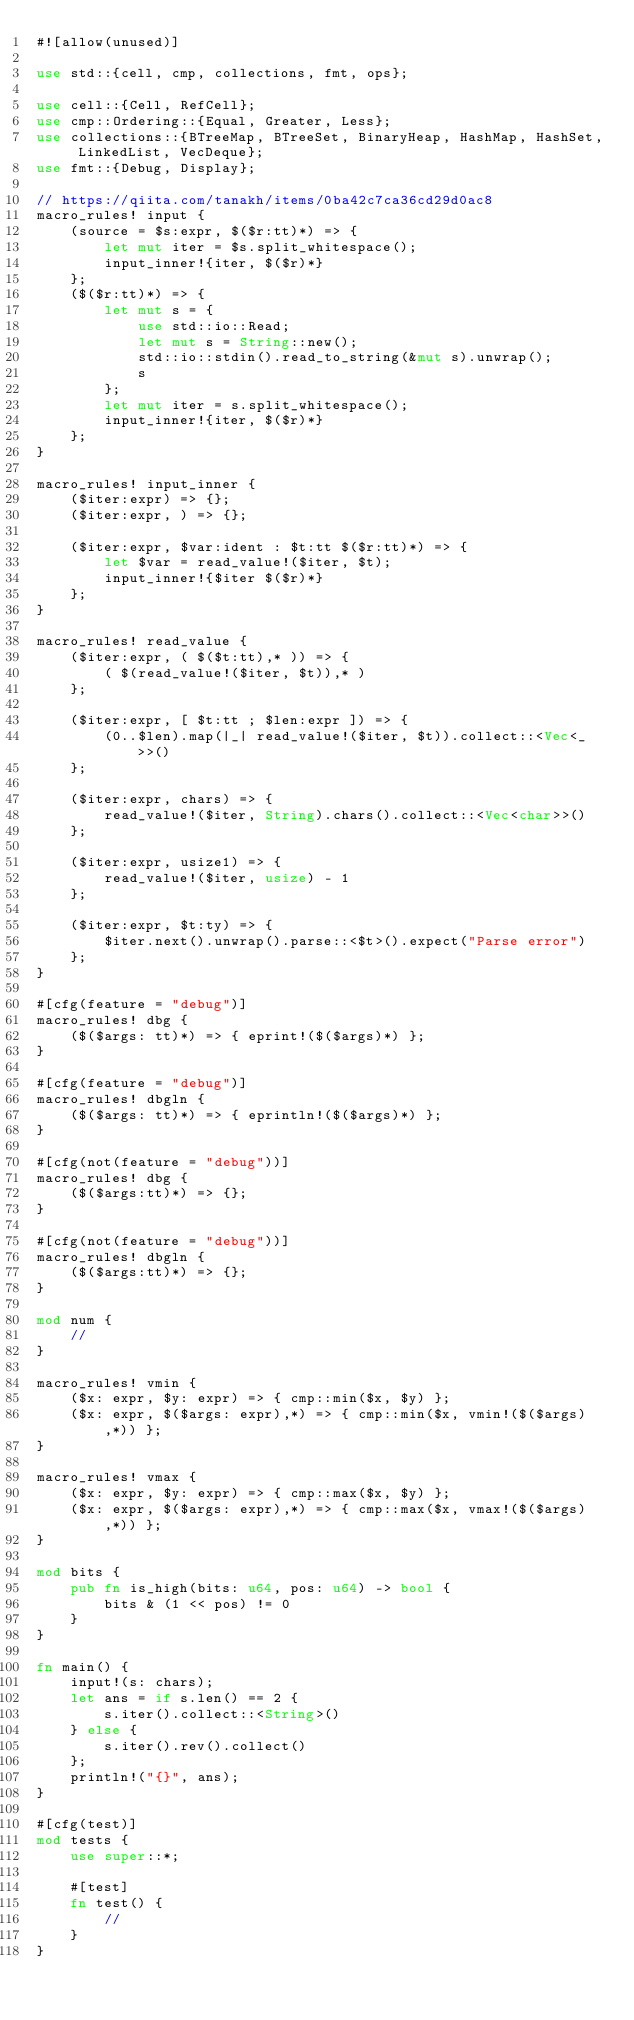<code> <loc_0><loc_0><loc_500><loc_500><_Rust_>#![allow(unused)]

use std::{cell, cmp, collections, fmt, ops};

use cell::{Cell, RefCell};
use cmp::Ordering::{Equal, Greater, Less};
use collections::{BTreeMap, BTreeSet, BinaryHeap, HashMap, HashSet, LinkedList, VecDeque};
use fmt::{Debug, Display};

// https://qiita.com/tanakh/items/0ba42c7ca36cd29d0ac8
macro_rules! input {
    (source = $s:expr, $($r:tt)*) => {
        let mut iter = $s.split_whitespace();
        input_inner!{iter, $($r)*}
    };
    ($($r:tt)*) => {
        let mut s = {
            use std::io::Read;
            let mut s = String::new();
            std::io::stdin().read_to_string(&mut s).unwrap();
            s
        };
        let mut iter = s.split_whitespace();
        input_inner!{iter, $($r)*}
    };
}

macro_rules! input_inner {
    ($iter:expr) => {};
    ($iter:expr, ) => {};

    ($iter:expr, $var:ident : $t:tt $($r:tt)*) => {
        let $var = read_value!($iter, $t);
        input_inner!{$iter $($r)*}
    };
}

macro_rules! read_value {
    ($iter:expr, ( $($t:tt),* )) => {
        ( $(read_value!($iter, $t)),* )
    };

    ($iter:expr, [ $t:tt ; $len:expr ]) => {
        (0..$len).map(|_| read_value!($iter, $t)).collect::<Vec<_>>()
    };

    ($iter:expr, chars) => {
        read_value!($iter, String).chars().collect::<Vec<char>>()
    };

    ($iter:expr, usize1) => {
        read_value!($iter, usize) - 1
    };

    ($iter:expr, $t:ty) => {
        $iter.next().unwrap().parse::<$t>().expect("Parse error")
    };
}

#[cfg(feature = "debug")]
macro_rules! dbg {
    ($($args: tt)*) => { eprint!($($args)*) };
}

#[cfg(feature = "debug")]
macro_rules! dbgln {
    ($($args: tt)*) => { eprintln!($($args)*) };
}

#[cfg(not(feature = "debug"))]
macro_rules! dbg {
    ($($args:tt)*) => {};
}

#[cfg(not(feature = "debug"))]
macro_rules! dbgln {
    ($($args:tt)*) => {};
}

mod num {
    //
}

macro_rules! vmin {
    ($x: expr, $y: expr) => { cmp::min($x, $y) };
    ($x: expr, $($args: expr),*) => { cmp::min($x, vmin!($($args),*)) };
}

macro_rules! vmax {
    ($x: expr, $y: expr) => { cmp::max($x, $y) };
    ($x: expr, $($args: expr),*) => { cmp::max($x, vmax!($($args),*)) };
}

mod bits {
    pub fn is_high(bits: u64, pos: u64) -> bool {
        bits & (1 << pos) != 0
    }
}

fn main() {
    input!(s: chars);
    let ans = if s.len() == 2 {
        s.iter().collect::<String>()
    } else {
        s.iter().rev().collect()
    };
    println!("{}", ans);
}

#[cfg(test)]
mod tests {
    use super::*;

    #[test]
    fn test() {
        //
    }
}
</code> 